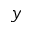<formula> <loc_0><loc_0><loc_500><loc_500>y</formula> 